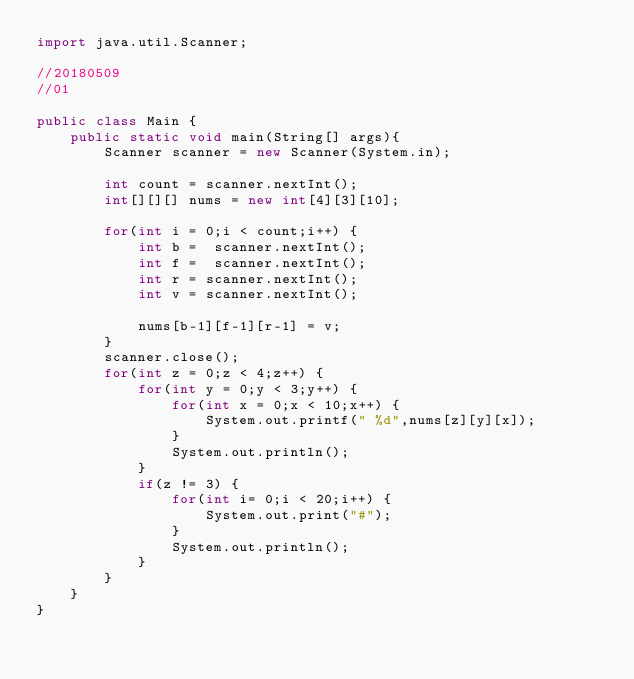Convert code to text. <code><loc_0><loc_0><loc_500><loc_500><_Java_>import java.util.Scanner;

//20180509
//01

public class Main {
    public static void main(String[] args){
		Scanner scanner = new Scanner(System.in);

		int count = scanner.nextInt();
		int[][][] nums = new int[4][3][10];

		for(int i = 0;i < count;i++) {
			int b =  scanner.nextInt();
			int f =  scanner.nextInt();
			int r = scanner.nextInt();
			int v = scanner.nextInt();

			nums[b-1][f-1][r-1] = v;
		}
		scanner.close();
		for(int z = 0;z < 4;z++) {
			for(int y = 0;y < 3;y++) {
				for(int x = 0;x < 10;x++) {
					System.out.printf(" %d",nums[z][y][x]);
				}
				System.out.println();
			}
			if(z != 3) {
				for(int i= 0;i < 20;i++) {
					System.out.print("#");
				}
				System.out.println();
			}
		}
    }
}
</code> 